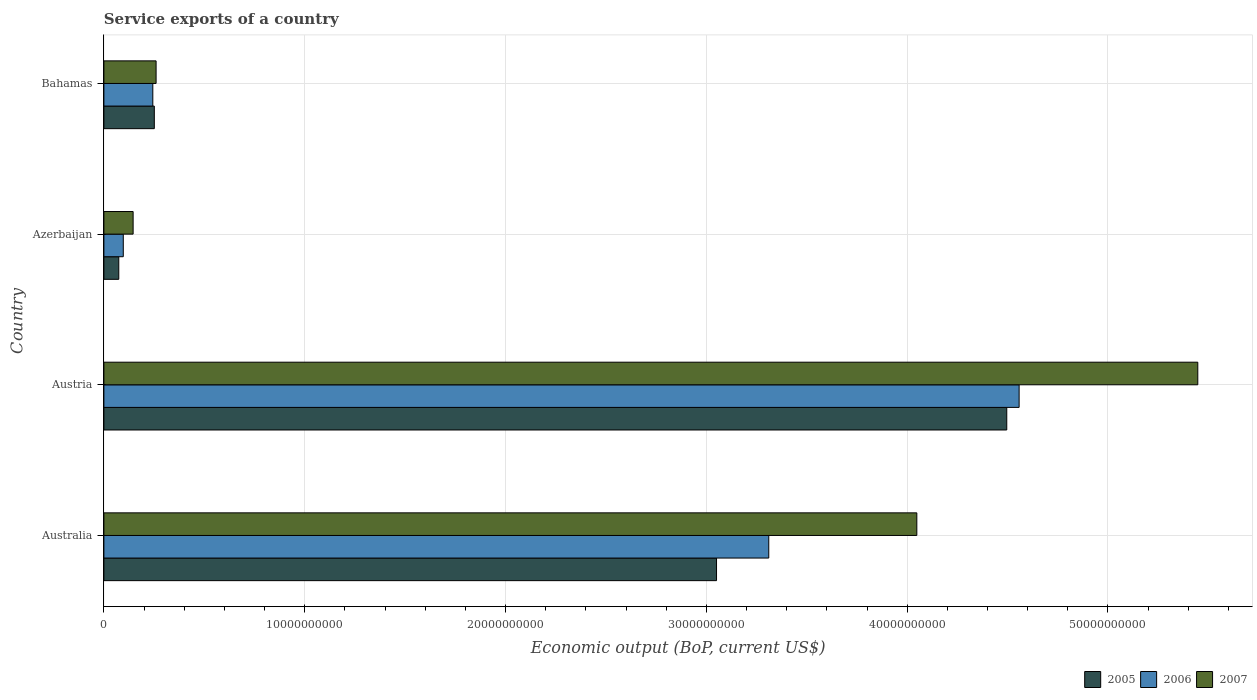How many groups of bars are there?
Offer a terse response. 4. What is the label of the 1st group of bars from the top?
Give a very brief answer. Bahamas. What is the service exports in 2007 in Azerbaijan?
Give a very brief answer. 1.46e+09. Across all countries, what is the maximum service exports in 2005?
Your answer should be compact. 4.50e+1. Across all countries, what is the minimum service exports in 2006?
Provide a short and direct response. 9.65e+08. In which country was the service exports in 2006 maximum?
Ensure brevity in your answer.  Austria. In which country was the service exports in 2007 minimum?
Offer a terse response. Azerbaijan. What is the total service exports in 2007 in the graph?
Offer a terse response. 9.90e+1. What is the difference between the service exports in 2007 in Australia and that in Austria?
Your response must be concise. -1.40e+1. What is the difference between the service exports in 2007 in Bahamas and the service exports in 2006 in Australia?
Your response must be concise. -3.05e+1. What is the average service exports in 2005 per country?
Offer a terse response. 1.97e+1. What is the difference between the service exports in 2007 and service exports in 2005 in Australia?
Offer a very short reply. 9.97e+09. What is the ratio of the service exports in 2006 in Austria to that in Azerbaijan?
Offer a terse response. 47.21. Is the service exports in 2005 in Australia less than that in Azerbaijan?
Offer a very short reply. No. What is the difference between the highest and the second highest service exports in 2005?
Keep it short and to the point. 1.45e+1. What is the difference between the highest and the lowest service exports in 2005?
Your answer should be compact. 4.42e+1. In how many countries, is the service exports in 2007 greater than the average service exports in 2007 taken over all countries?
Offer a terse response. 2. Is the sum of the service exports in 2006 in Australia and Austria greater than the maximum service exports in 2007 across all countries?
Ensure brevity in your answer.  Yes. How many bars are there?
Provide a succinct answer. 12. Are all the bars in the graph horizontal?
Ensure brevity in your answer.  Yes. How many countries are there in the graph?
Make the answer very short. 4. What is the difference between two consecutive major ticks on the X-axis?
Make the answer very short. 1.00e+1. What is the title of the graph?
Your answer should be very brief. Service exports of a country. Does "1967" appear as one of the legend labels in the graph?
Provide a short and direct response. No. What is the label or title of the X-axis?
Your response must be concise. Economic output (BoP, current US$). What is the label or title of the Y-axis?
Provide a short and direct response. Country. What is the Economic output (BoP, current US$) in 2005 in Australia?
Give a very brief answer. 3.05e+1. What is the Economic output (BoP, current US$) in 2006 in Australia?
Provide a succinct answer. 3.31e+1. What is the Economic output (BoP, current US$) in 2007 in Australia?
Your response must be concise. 4.05e+1. What is the Economic output (BoP, current US$) of 2005 in Austria?
Keep it short and to the point. 4.50e+1. What is the Economic output (BoP, current US$) in 2006 in Austria?
Offer a terse response. 4.56e+1. What is the Economic output (BoP, current US$) in 2007 in Austria?
Ensure brevity in your answer.  5.45e+1. What is the Economic output (BoP, current US$) in 2005 in Azerbaijan?
Keep it short and to the point. 7.41e+08. What is the Economic output (BoP, current US$) of 2006 in Azerbaijan?
Offer a terse response. 9.65e+08. What is the Economic output (BoP, current US$) in 2007 in Azerbaijan?
Keep it short and to the point. 1.46e+09. What is the Economic output (BoP, current US$) of 2005 in Bahamas?
Your response must be concise. 2.51e+09. What is the Economic output (BoP, current US$) of 2006 in Bahamas?
Your answer should be very brief. 2.44e+09. What is the Economic output (BoP, current US$) of 2007 in Bahamas?
Provide a short and direct response. 2.60e+09. Across all countries, what is the maximum Economic output (BoP, current US$) in 2005?
Offer a very short reply. 4.50e+1. Across all countries, what is the maximum Economic output (BoP, current US$) in 2006?
Your answer should be compact. 4.56e+1. Across all countries, what is the maximum Economic output (BoP, current US$) in 2007?
Make the answer very short. 5.45e+1. Across all countries, what is the minimum Economic output (BoP, current US$) in 2005?
Your answer should be very brief. 7.41e+08. Across all countries, what is the minimum Economic output (BoP, current US$) in 2006?
Make the answer very short. 9.65e+08. Across all countries, what is the minimum Economic output (BoP, current US$) of 2007?
Offer a very short reply. 1.46e+09. What is the total Economic output (BoP, current US$) of 2005 in the graph?
Keep it short and to the point. 7.87e+1. What is the total Economic output (BoP, current US$) of 2006 in the graph?
Offer a terse response. 8.21e+1. What is the total Economic output (BoP, current US$) in 2007 in the graph?
Offer a very short reply. 9.90e+1. What is the difference between the Economic output (BoP, current US$) in 2005 in Australia and that in Austria?
Your answer should be compact. -1.45e+1. What is the difference between the Economic output (BoP, current US$) in 2006 in Australia and that in Austria?
Your answer should be compact. -1.25e+1. What is the difference between the Economic output (BoP, current US$) of 2007 in Australia and that in Austria?
Offer a very short reply. -1.40e+1. What is the difference between the Economic output (BoP, current US$) in 2005 in Australia and that in Azerbaijan?
Keep it short and to the point. 2.98e+1. What is the difference between the Economic output (BoP, current US$) of 2006 in Australia and that in Azerbaijan?
Offer a very short reply. 3.21e+1. What is the difference between the Economic output (BoP, current US$) of 2007 in Australia and that in Azerbaijan?
Give a very brief answer. 3.90e+1. What is the difference between the Economic output (BoP, current US$) in 2005 in Australia and that in Bahamas?
Your response must be concise. 2.80e+1. What is the difference between the Economic output (BoP, current US$) in 2006 in Australia and that in Bahamas?
Your answer should be very brief. 3.07e+1. What is the difference between the Economic output (BoP, current US$) in 2007 in Australia and that in Bahamas?
Your response must be concise. 3.79e+1. What is the difference between the Economic output (BoP, current US$) of 2005 in Austria and that in Azerbaijan?
Ensure brevity in your answer.  4.42e+1. What is the difference between the Economic output (BoP, current US$) of 2006 in Austria and that in Azerbaijan?
Ensure brevity in your answer.  4.46e+1. What is the difference between the Economic output (BoP, current US$) in 2007 in Austria and that in Azerbaijan?
Ensure brevity in your answer.  5.30e+1. What is the difference between the Economic output (BoP, current US$) in 2005 in Austria and that in Bahamas?
Provide a succinct answer. 4.24e+1. What is the difference between the Economic output (BoP, current US$) of 2006 in Austria and that in Bahamas?
Make the answer very short. 4.31e+1. What is the difference between the Economic output (BoP, current US$) in 2007 in Austria and that in Bahamas?
Provide a succinct answer. 5.19e+1. What is the difference between the Economic output (BoP, current US$) of 2005 in Azerbaijan and that in Bahamas?
Give a very brief answer. -1.77e+09. What is the difference between the Economic output (BoP, current US$) in 2006 in Azerbaijan and that in Bahamas?
Offer a very short reply. -1.47e+09. What is the difference between the Economic output (BoP, current US$) in 2007 in Azerbaijan and that in Bahamas?
Keep it short and to the point. -1.14e+09. What is the difference between the Economic output (BoP, current US$) of 2005 in Australia and the Economic output (BoP, current US$) of 2006 in Austria?
Offer a terse response. -1.51e+1. What is the difference between the Economic output (BoP, current US$) in 2005 in Australia and the Economic output (BoP, current US$) in 2007 in Austria?
Your answer should be very brief. -2.40e+1. What is the difference between the Economic output (BoP, current US$) of 2006 in Australia and the Economic output (BoP, current US$) of 2007 in Austria?
Provide a short and direct response. -2.14e+1. What is the difference between the Economic output (BoP, current US$) of 2005 in Australia and the Economic output (BoP, current US$) of 2006 in Azerbaijan?
Provide a short and direct response. 2.95e+1. What is the difference between the Economic output (BoP, current US$) of 2005 in Australia and the Economic output (BoP, current US$) of 2007 in Azerbaijan?
Give a very brief answer. 2.91e+1. What is the difference between the Economic output (BoP, current US$) in 2006 in Australia and the Economic output (BoP, current US$) in 2007 in Azerbaijan?
Your answer should be very brief. 3.17e+1. What is the difference between the Economic output (BoP, current US$) of 2005 in Australia and the Economic output (BoP, current US$) of 2006 in Bahamas?
Your answer should be very brief. 2.81e+1. What is the difference between the Economic output (BoP, current US$) of 2005 in Australia and the Economic output (BoP, current US$) of 2007 in Bahamas?
Give a very brief answer. 2.79e+1. What is the difference between the Economic output (BoP, current US$) of 2006 in Australia and the Economic output (BoP, current US$) of 2007 in Bahamas?
Give a very brief answer. 3.05e+1. What is the difference between the Economic output (BoP, current US$) of 2005 in Austria and the Economic output (BoP, current US$) of 2006 in Azerbaijan?
Keep it short and to the point. 4.40e+1. What is the difference between the Economic output (BoP, current US$) of 2005 in Austria and the Economic output (BoP, current US$) of 2007 in Azerbaijan?
Provide a succinct answer. 4.35e+1. What is the difference between the Economic output (BoP, current US$) of 2006 in Austria and the Economic output (BoP, current US$) of 2007 in Azerbaijan?
Offer a terse response. 4.41e+1. What is the difference between the Economic output (BoP, current US$) of 2005 in Austria and the Economic output (BoP, current US$) of 2006 in Bahamas?
Keep it short and to the point. 4.25e+1. What is the difference between the Economic output (BoP, current US$) of 2005 in Austria and the Economic output (BoP, current US$) of 2007 in Bahamas?
Offer a terse response. 4.24e+1. What is the difference between the Economic output (BoP, current US$) in 2006 in Austria and the Economic output (BoP, current US$) in 2007 in Bahamas?
Your answer should be very brief. 4.30e+1. What is the difference between the Economic output (BoP, current US$) in 2005 in Azerbaijan and the Economic output (BoP, current US$) in 2006 in Bahamas?
Offer a very short reply. -1.69e+09. What is the difference between the Economic output (BoP, current US$) of 2005 in Azerbaijan and the Economic output (BoP, current US$) of 2007 in Bahamas?
Your answer should be very brief. -1.86e+09. What is the difference between the Economic output (BoP, current US$) in 2006 in Azerbaijan and the Economic output (BoP, current US$) in 2007 in Bahamas?
Your answer should be compact. -1.63e+09. What is the average Economic output (BoP, current US$) of 2005 per country?
Make the answer very short. 1.97e+1. What is the average Economic output (BoP, current US$) of 2006 per country?
Give a very brief answer. 2.05e+1. What is the average Economic output (BoP, current US$) of 2007 per country?
Your answer should be compact. 2.48e+1. What is the difference between the Economic output (BoP, current US$) of 2005 and Economic output (BoP, current US$) of 2006 in Australia?
Make the answer very short. -2.60e+09. What is the difference between the Economic output (BoP, current US$) of 2005 and Economic output (BoP, current US$) of 2007 in Australia?
Offer a terse response. -9.97e+09. What is the difference between the Economic output (BoP, current US$) in 2006 and Economic output (BoP, current US$) in 2007 in Australia?
Keep it short and to the point. -7.37e+09. What is the difference between the Economic output (BoP, current US$) in 2005 and Economic output (BoP, current US$) in 2006 in Austria?
Keep it short and to the point. -6.15e+08. What is the difference between the Economic output (BoP, current US$) of 2005 and Economic output (BoP, current US$) of 2007 in Austria?
Your answer should be very brief. -9.51e+09. What is the difference between the Economic output (BoP, current US$) of 2006 and Economic output (BoP, current US$) of 2007 in Austria?
Ensure brevity in your answer.  -8.90e+09. What is the difference between the Economic output (BoP, current US$) in 2005 and Economic output (BoP, current US$) in 2006 in Azerbaijan?
Offer a very short reply. -2.24e+08. What is the difference between the Economic output (BoP, current US$) of 2005 and Economic output (BoP, current US$) of 2007 in Azerbaijan?
Keep it short and to the point. -7.14e+08. What is the difference between the Economic output (BoP, current US$) in 2006 and Economic output (BoP, current US$) in 2007 in Azerbaijan?
Your response must be concise. -4.90e+08. What is the difference between the Economic output (BoP, current US$) of 2005 and Economic output (BoP, current US$) of 2006 in Bahamas?
Your answer should be compact. 7.48e+07. What is the difference between the Economic output (BoP, current US$) in 2005 and Economic output (BoP, current US$) in 2007 in Bahamas?
Give a very brief answer. -8.84e+07. What is the difference between the Economic output (BoP, current US$) in 2006 and Economic output (BoP, current US$) in 2007 in Bahamas?
Give a very brief answer. -1.63e+08. What is the ratio of the Economic output (BoP, current US$) of 2005 in Australia to that in Austria?
Provide a succinct answer. 0.68. What is the ratio of the Economic output (BoP, current US$) in 2006 in Australia to that in Austria?
Your response must be concise. 0.73. What is the ratio of the Economic output (BoP, current US$) in 2007 in Australia to that in Austria?
Provide a succinct answer. 0.74. What is the ratio of the Economic output (BoP, current US$) of 2005 in Australia to that in Azerbaijan?
Your response must be concise. 41.14. What is the ratio of the Economic output (BoP, current US$) in 2006 in Australia to that in Azerbaijan?
Give a very brief answer. 34.3. What is the ratio of the Economic output (BoP, current US$) of 2007 in Australia to that in Azerbaijan?
Your response must be concise. 27.81. What is the ratio of the Economic output (BoP, current US$) of 2005 in Australia to that in Bahamas?
Offer a very short reply. 12.15. What is the ratio of the Economic output (BoP, current US$) of 2006 in Australia to that in Bahamas?
Ensure brevity in your answer.  13.59. What is the ratio of the Economic output (BoP, current US$) of 2007 in Australia to that in Bahamas?
Your response must be concise. 15.57. What is the ratio of the Economic output (BoP, current US$) in 2005 in Austria to that in Azerbaijan?
Your response must be concise. 60.64. What is the ratio of the Economic output (BoP, current US$) of 2006 in Austria to that in Azerbaijan?
Offer a very short reply. 47.21. What is the ratio of the Economic output (BoP, current US$) in 2007 in Austria to that in Azerbaijan?
Make the answer very short. 37.43. What is the ratio of the Economic output (BoP, current US$) of 2005 in Austria to that in Bahamas?
Your answer should be very brief. 17.91. What is the ratio of the Economic output (BoP, current US$) in 2006 in Austria to that in Bahamas?
Ensure brevity in your answer.  18.71. What is the ratio of the Economic output (BoP, current US$) in 2007 in Austria to that in Bahamas?
Ensure brevity in your answer.  20.96. What is the ratio of the Economic output (BoP, current US$) in 2005 in Azerbaijan to that in Bahamas?
Offer a terse response. 0.3. What is the ratio of the Economic output (BoP, current US$) in 2006 in Azerbaijan to that in Bahamas?
Your response must be concise. 0.4. What is the ratio of the Economic output (BoP, current US$) in 2007 in Azerbaijan to that in Bahamas?
Offer a terse response. 0.56. What is the difference between the highest and the second highest Economic output (BoP, current US$) of 2005?
Provide a succinct answer. 1.45e+1. What is the difference between the highest and the second highest Economic output (BoP, current US$) of 2006?
Your response must be concise. 1.25e+1. What is the difference between the highest and the second highest Economic output (BoP, current US$) in 2007?
Provide a succinct answer. 1.40e+1. What is the difference between the highest and the lowest Economic output (BoP, current US$) of 2005?
Your answer should be compact. 4.42e+1. What is the difference between the highest and the lowest Economic output (BoP, current US$) in 2006?
Offer a very short reply. 4.46e+1. What is the difference between the highest and the lowest Economic output (BoP, current US$) in 2007?
Your answer should be compact. 5.30e+1. 